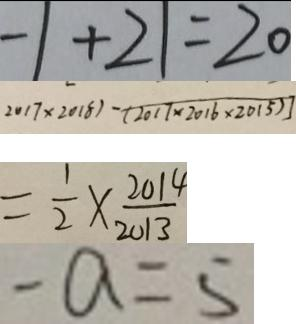Convert formula to latex. <formula><loc_0><loc_0><loc_500><loc_500>- 1 + 2 1 = 2 0 
 2 0 1 7 \times 2 0 1 8 ) - ( 2 0 1 7 \times 2 0 1 6 \times 2 0 1 5 ) ] 
 = \frac { 1 } { 2 } \times \frac { 2 0 1 4 } { 2 0 1 3 } 
 - a = 5</formula> 